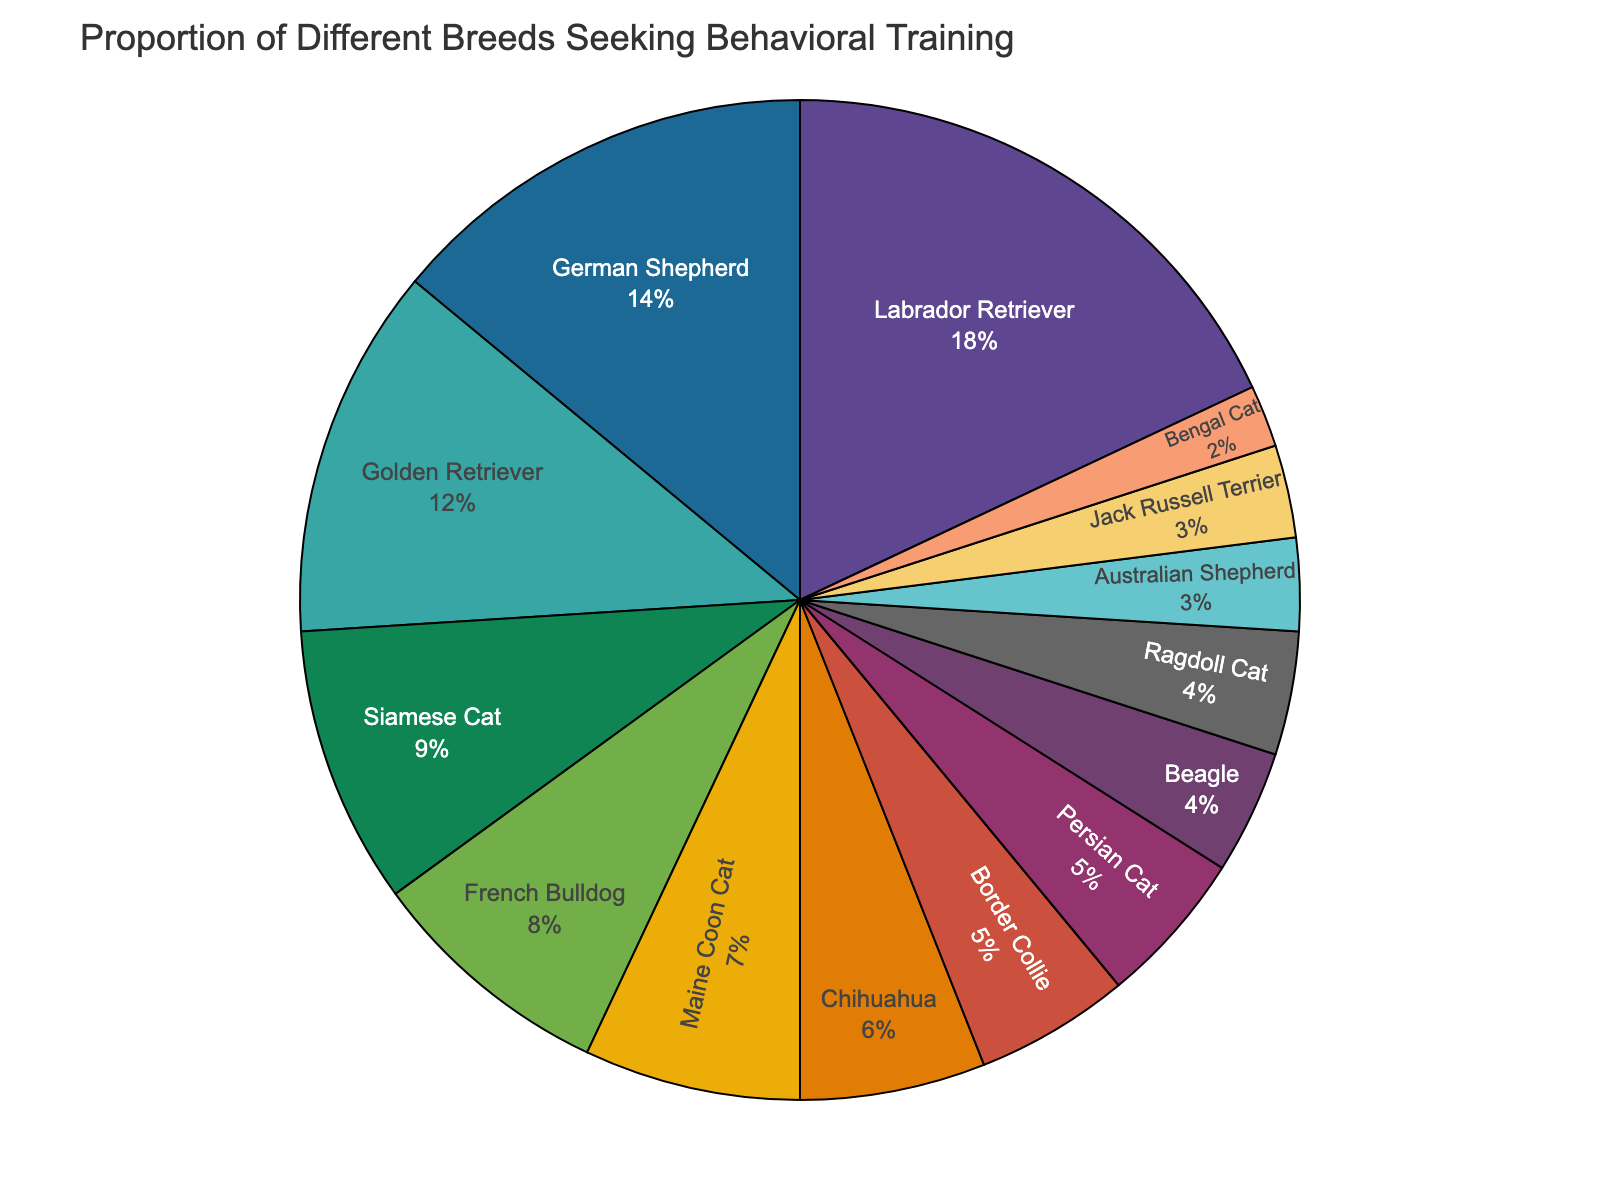Which breed has the highest percentage seeking behavioral training? The pie chart shows that the Labrador Retriever has the largest segment. By checking the listed percentages, the highest one is 18%, which corresponds to the Labrador Retriever.
Answer: Labrador Retriever Which two breeds together make up the largest proportion of animals seeking behavioral training? By observing the chart, we notice the largest segments belong to the Labrador Retriever and German Shepherd. Summing their percentages (18 + 14) gives us a total of 32%.
Answer: Labrador Retriever and German Shepherd What proportion of the total do the three cat breeds (Siamese Cat, Maine Coon Cat, Persian Cat) make up? According to the chart, Siamese Cat has 9%, Maine Coon Cat has 7%, and Persian Cat has 5%. Adding these up ((9 + 7) + 5) gives us a total of 21%.
Answer: 21% Is the percentage of German Shepherds seeking training greater than the combined percentage of Beagles and Border Collies? The percentage for German Shepherds is 14%. Beagles have 4%, and Border Collies have 5%. Summing the latter two (4 + 5) gives 9%, which is less than 14%.
Answer: Yes How does the proportion of Chihuahua compare to that of the French Bulldog? The pie chart indicates that Chihuahuas make up 6%, while French Bulldogs have 8%. Therefore, French Bulldogs have a greater proportion.
Answer: French Bulldog What is the total percentage for dog breeds seeking behavioral training? Summing up the percentages of all dog breeds: Labrador Retriever (18), German Shepherd (14), Golden Retriever (12), French Bulldog (8), Chihuahua (6), Border Collie (5), Beagle (4), Australian Shepherd (3), Jack Russell Terrier (3) gives us 73%.
Answer: 73% How do the percentages of Labrador Retrievers and Golden Retrievers combined compare to the German Shepherds? Combining the Labrador Retriever (18%) and Golden Retriever (12%) gives us 30%, which is greater than the German Shepherd’s 14%.
Answer: Labrador and Golden Retrievers combined Which cat breed has the smallest percentage seeking behavioral training? Observing the chart, Bengal Cats have the smallest segment, which is 2%.
Answer: Bengal Cat 